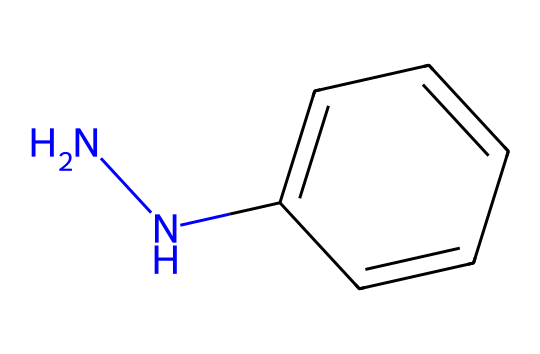How many nitrogen atoms does phenylhydrazine contain? By evaluating the SMILES representation, we can identify two nitrogen (N) atoms represented by the "NN" part at the beginning of the SMILES.
Answer: 2 What is the molecular formula of phenylhydrazine? From the SMILES structure, counting the carbon (C), hydrogen (H), and nitrogen (N) atoms leads us to determine the molecular formula as C6H8N2.
Answer: C6H8N2 Is phenylhydrazine aromatic? The presence of a benzene ring in the structure (c1ccccc1) indicates that it is aromatic, as it contains conjugated pi bonds in a cyclic structure.
Answer: Yes What functional groups are present in phenylhydrazine? The structure has an amine functional group (NH) due to the nitrogen atoms, confirming the hydrazine classification.
Answer: Amine What type of reaction might phenylhydrazine commonly undergo in pharmaceutical manufacturing? Phenylhydrazine is known to undergo condensation reactions, resulting in the formation of hydrazones, which are often utilized in synthesizing pharmaceuticals.
Answer: Condensation What role does phenylhydrazine play in biological systems? It acts as a reagent in the identification of ketones and aldehydes, highlighting its significance in various biological assays.
Answer: Reagent What is the significance of phenylhydrazine in the context of rehabilitation programs? Working with phenylhydrazine allows rehabilitated individuals to gain skills in chemical manufacturing, providing them with employment opportunities in industry.
Answer: Employment skills 